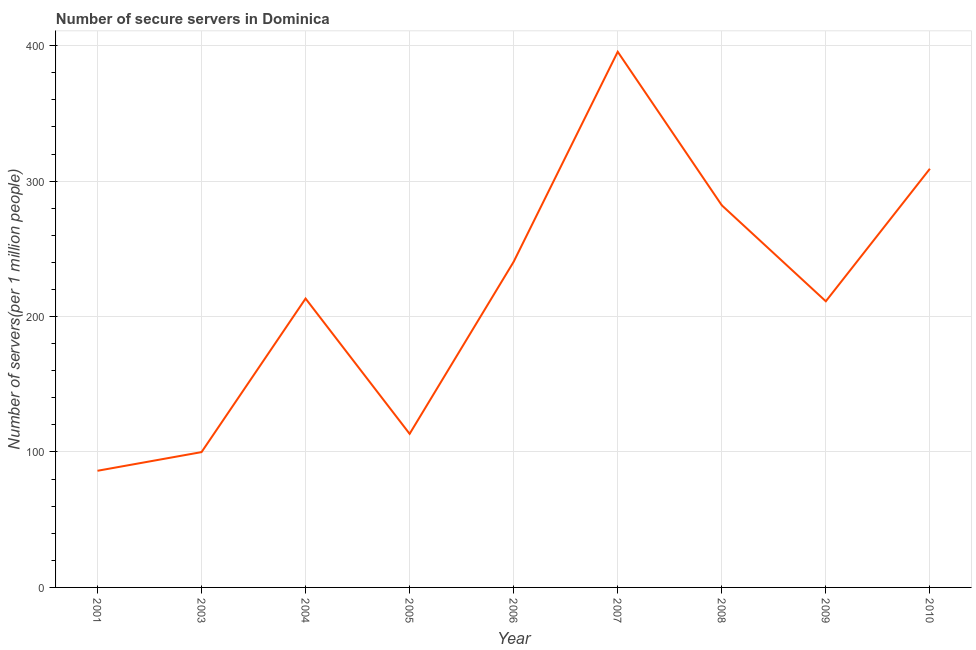What is the number of secure internet servers in 2008?
Make the answer very short. 282.16. Across all years, what is the maximum number of secure internet servers?
Your answer should be compact. 395.51. Across all years, what is the minimum number of secure internet servers?
Keep it short and to the point. 86.13. In which year was the number of secure internet servers minimum?
Make the answer very short. 2001. What is the sum of the number of secure internet servers?
Provide a succinct answer. 1951.33. What is the difference between the number of secure internet servers in 2001 and 2004?
Keep it short and to the point. -127.16. What is the average number of secure internet servers per year?
Your answer should be very brief. 216.81. What is the median number of secure internet servers?
Ensure brevity in your answer.  213.3. What is the ratio of the number of secure internet servers in 2007 to that in 2009?
Give a very brief answer. 1.87. What is the difference between the highest and the second highest number of secure internet servers?
Provide a short and direct response. 86.38. Is the sum of the number of secure internet servers in 2008 and 2009 greater than the maximum number of secure internet servers across all years?
Ensure brevity in your answer.  Yes. What is the difference between the highest and the lowest number of secure internet servers?
Your response must be concise. 309.38. In how many years, is the number of secure internet servers greater than the average number of secure internet servers taken over all years?
Your answer should be compact. 4. Does the number of secure internet servers monotonically increase over the years?
Offer a very short reply. No. How many lines are there?
Provide a short and direct response. 1. How many years are there in the graph?
Offer a terse response. 9. Are the values on the major ticks of Y-axis written in scientific E-notation?
Make the answer very short. No. Does the graph contain grids?
Your answer should be very brief. Yes. What is the title of the graph?
Your answer should be very brief. Number of secure servers in Dominica. What is the label or title of the X-axis?
Make the answer very short. Year. What is the label or title of the Y-axis?
Make the answer very short. Number of servers(per 1 million people). What is the Number of servers(per 1 million people) in 2001?
Offer a very short reply. 86.13. What is the Number of servers(per 1 million people) in 2003?
Your response must be concise. 99.92. What is the Number of servers(per 1 million people) of 2004?
Provide a succinct answer. 213.3. What is the Number of servers(per 1 million people) of 2005?
Give a very brief answer. 113.41. What is the Number of servers(per 1 million people) in 2006?
Offer a terse response. 240.49. What is the Number of servers(per 1 million people) in 2007?
Give a very brief answer. 395.51. What is the Number of servers(per 1 million people) in 2008?
Keep it short and to the point. 282.16. What is the Number of servers(per 1 million people) of 2009?
Make the answer very short. 211.28. What is the Number of servers(per 1 million people) of 2010?
Make the answer very short. 309.13. What is the difference between the Number of servers(per 1 million people) in 2001 and 2003?
Give a very brief answer. -13.78. What is the difference between the Number of servers(per 1 million people) in 2001 and 2004?
Offer a terse response. -127.16. What is the difference between the Number of servers(per 1 million people) in 2001 and 2005?
Offer a terse response. -27.27. What is the difference between the Number of servers(per 1 million people) in 2001 and 2006?
Offer a very short reply. -154.35. What is the difference between the Number of servers(per 1 million people) in 2001 and 2007?
Your response must be concise. -309.38. What is the difference between the Number of servers(per 1 million people) in 2001 and 2008?
Give a very brief answer. -196.03. What is the difference between the Number of servers(per 1 million people) in 2001 and 2009?
Make the answer very short. -125.15. What is the difference between the Number of servers(per 1 million people) in 2001 and 2010?
Your answer should be very brief. -223. What is the difference between the Number of servers(per 1 million people) in 2003 and 2004?
Offer a very short reply. -113.38. What is the difference between the Number of servers(per 1 million people) in 2003 and 2005?
Keep it short and to the point. -13.49. What is the difference between the Number of servers(per 1 million people) in 2003 and 2006?
Make the answer very short. -140.57. What is the difference between the Number of servers(per 1 million people) in 2003 and 2007?
Ensure brevity in your answer.  -295.59. What is the difference between the Number of servers(per 1 million people) in 2003 and 2008?
Your answer should be very brief. -182.25. What is the difference between the Number of servers(per 1 million people) in 2003 and 2009?
Offer a very short reply. -111.37. What is the difference between the Number of servers(per 1 million people) in 2003 and 2010?
Provide a succinct answer. -209.21. What is the difference between the Number of servers(per 1 million people) in 2004 and 2005?
Ensure brevity in your answer.  99.89. What is the difference between the Number of servers(per 1 million people) in 2004 and 2006?
Offer a terse response. -27.19. What is the difference between the Number of servers(per 1 million people) in 2004 and 2007?
Give a very brief answer. -182.21. What is the difference between the Number of servers(per 1 million people) in 2004 and 2008?
Your response must be concise. -68.87. What is the difference between the Number of servers(per 1 million people) in 2004 and 2009?
Provide a short and direct response. 2.01. What is the difference between the Number of servers(per 1 million people) in 2004 and 2010?
Offer a terse response. -95.84. What is the difference between the Number of servers(per 1 million people) in 2005 and 2006?
Make the answer very short. -127.08. What is the difference between the Number of servers(per 1 million people) in 2005 and 2007?
Provide a succinct answer. -282.1. What is the difference between the Number of servers(per 1 million people) in 2005 and 2008?
Your answer should be very brief. -168.76. What is the difference between the Number of servers(per 1 million people) in 2005 and 2009?
Provide a short and direct response. -97.87. What is the difference between the Number of servers(per 1 million people) in 2005 and 2010?
Offer a terse response. -195.72. What is the difference between the Number of servers(per 1 million people) in 2006 and 2007?
Ensure brevity in your answer.  -155.02. What is the difference between the Number of servers(per 1 million people) in 2006 and 2008?
Your answer should be very brief. -41.68. What is the difference between the Number of servers(per 1 million people) in 2006 and 2009?
Make the answer very short. 29.2. What is the difference between the Number of servers(per 1 million people) in 2006 and 2010?
Offer a terse response. -68.65. What is the difference between the Number of servers(per 1 million people) in 2007 and 2008?
Keep it short and to the point. 113.35. What is the difference between the Number of servers(per 1 million people) in 2007 and 2009?
Ensure brevity in your answer.  184.23. What is the difference between the Number of servers(per 1 million people) in 2007 and 2010?
Keep it short and to the point. 86.38. What is the difference between the Number of servers(per 1 million people) in 2008 and 2009?
Offer a very short reply. 70.88. What is the difference between the Number of servers(per 1 million people) in 2008 and 2010?
Give a very brief answer. -26.97. What is the difference between the Number of servers(per 1 million people) in 2009 and 2010?
Your response must be concise. -97.85. What is the ratio of the Number of servers(per 1 million people) in 2001 to that in 2003?
Provide a succinct answer. 0.86. What is the ratio of the Number of servers(per 1 million people) in 2001 to that in 2004?
Give a very brief answer. 0.4. What is the ratio of the Number of servers(per 1 million people) in 2001 to that in 2005?
Ensure brevity in your answer.  0.76. What is the ratio of the Number of servers(per 1 million people) in 2001 to that in 2006?
Offer a terse response. 0.36. What is the ratio of the Number of servers(per 1 million people) in 2001 to that in 2007?
Your answer should be compact. 0.22. What is the ratio of the Number of servers(per 1 million people) in 2001 to that in 2008?
Keep it short and to the point. 0.3. What is the ratio of the Number of servers(per 1 million people) in 2001 to that in 2009?
Your answer should be very brief. 0.41. What is the ratio of the Number of servers(per 1 million people) in 2001 to that in 2010?
Give a very brief answer. 0.28. What is the ratio of the Number of servers(per 1 million people) in 2003 to that in 2004?
Offer a terse response. 0.47. What is the ratio of the Number of servers(per 1 million people) in 2003 to that in 2005?
Your answer should be compact. 0.88. What is the ratio of the Number of servers(per 1 million people) in 2003 to that in 2006?
Your response must be concise. 0.41. What is the ratio of the Number of servers(per 1 million people) in 2003 to that in 2007?
Provide a succinct answer. 0.25. What is the ratio of the Number of servers(per 1 million people) in 2003 to that in 2008?
Your response must be concise. 0.35. What is the ratio of the Number of servers(per 1 million people) in 2003 to that in 2009?
Provide a short and direct response. 0.47. What is the ratio of the Number of servers(per 1 million people) in 2003 to that in 2010?
Offer a very short reply. 0.32. What is the ratio of the Number of servers(per 1 million people) in 2004 to that in 2005?
Ensure brevity in your answer.  1.88. What is the ratio of the Number of servers(per 1 million people) in 2004 to that in 2006?
Your response must be concise. 0.89. What is the ratio of the Number of servers(per 1 million people) in 2004 to that in 2007?
Keep it short and to the point. 0.54. What is the ratio of the Number of servers(per 1 million people) in 2004 to that in 2008?
Keep it short and to the point. 0.76. What is the ratio of the Number of servers(per 1 million people) in 2004 to that in 2010?
Keep it short and to the point. 0.69. What is the ratio of the Number of servers(per 1 million people) in 2005 to that in 2006?
Give a very brief answer. 0.47. What is the ratio of the Number of servers(per 1 million people) in 2005 to that in 2007?
Provide a short and direct response. 0.29. What is the ratio of the Number of servers(per 1 million people) in 2005 to that in 2008?
Ensure brevity in your answer.  0.4. What is the ratio of the Number of servers(per 1 million people) in 2005 to that in 2009?
Provide a short and direct response. 0.54. What is the ratio of the Number of servers(per 1 million people) in 2005 to that in 2010?
Offer a terse response. 0.37. What is the ratio of the Number of servers(per 1 million people) in 2006 to that in 2007?
Give a very brief answer. 0.61. What is the ratio of the Number of servers(per 1 million people) in 2006 to that in 2008?
Provide a short and direct response. 0.85. What is the ratio of the Number of servers(per 1 million people) in 2006 to that in 2009?
Make the answer very short. 1.14. What is the ratio of the Number of servers(per 1 million people) in 2006 to that in 2010?
Offer a terse response. 0.78. What is the ratio of the Number of servers(per 1 million people) in 2007 to that in 2008?
Offer a very short reply. 1.4. What is the ratio of the Number of servers(per 1 million people) in 2007 to that in 2009?
Ensure brevity in your answer.  1.87. What is the ratio of the Number of servers(per 1 million people) in 2007 to that in 2010?
Make the answer very short. 1.28. What is the ratio of the Number of servers(per 1 million people) in 2008 to that in 2009?
Ensure brevity in your answer.  1.33. What is the ratio of the Number of servers(per 1 million people) in 2008 to that in 2010?
Offer a very short reply. 0.91. What is the ratio of the Number of servers(per 1 million people) in 2009 to that in 2010?
Ensure brevity in your answer.  0.68. 